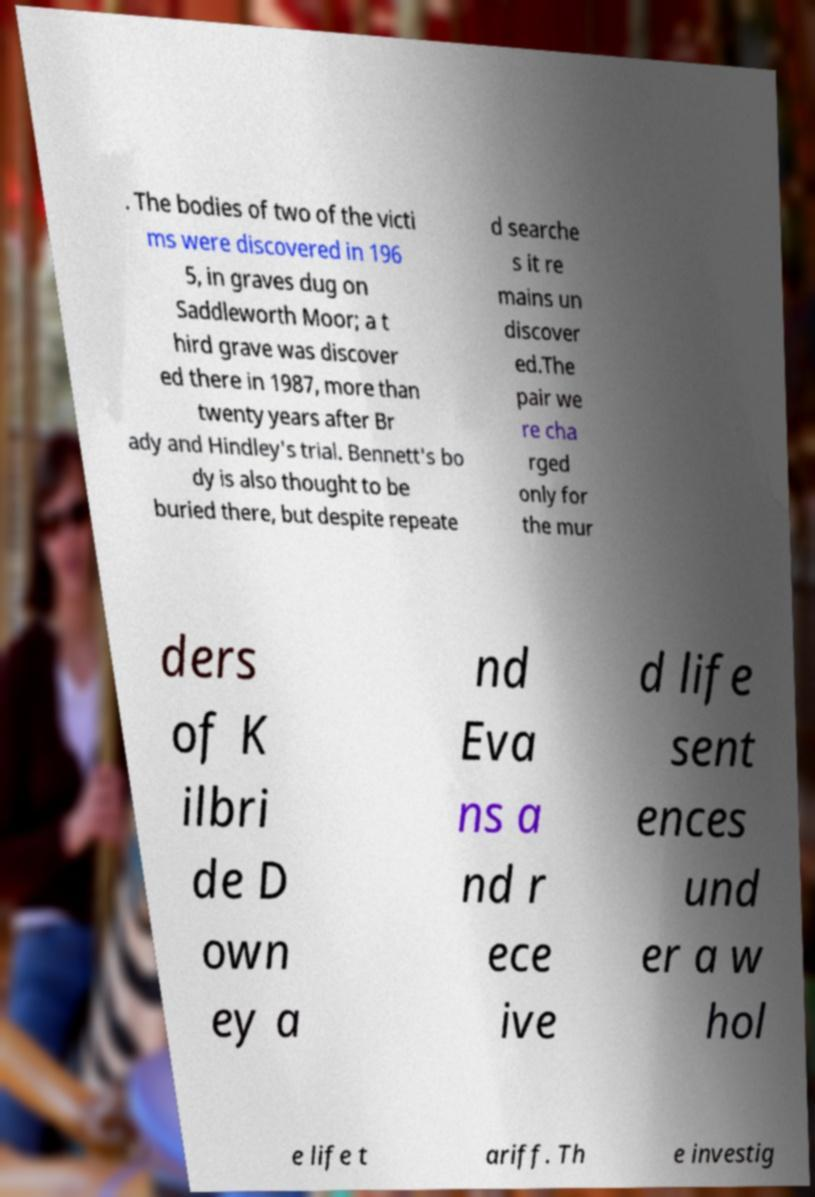Please read and relay the text visible in this image. What does it say? . The bodies of two of the victi ms were discovered in 196 5, in graves dug on Saddleworth Moor; a t hird grave was discover ed there in 1987, more than twenty years after Br ady and Hindley's trial. Bennett's bo dy is also thought to be buried there, but despite repeate d searche s it re mains un discover ed.The pair we re cha rged only for the mur ders of K ilbri de D own ey a nd Eva ns a nd r ece ive d life sent ences und er a w hol e life t ariff. Th e investig 